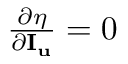<formula> <loc_0><loc_0><loc_500><loc_500>\begin{array} { r } { \frac { \partial \eta } { { \partial { { I } _ { u } } } } = 0 } \end{array}</formula> 